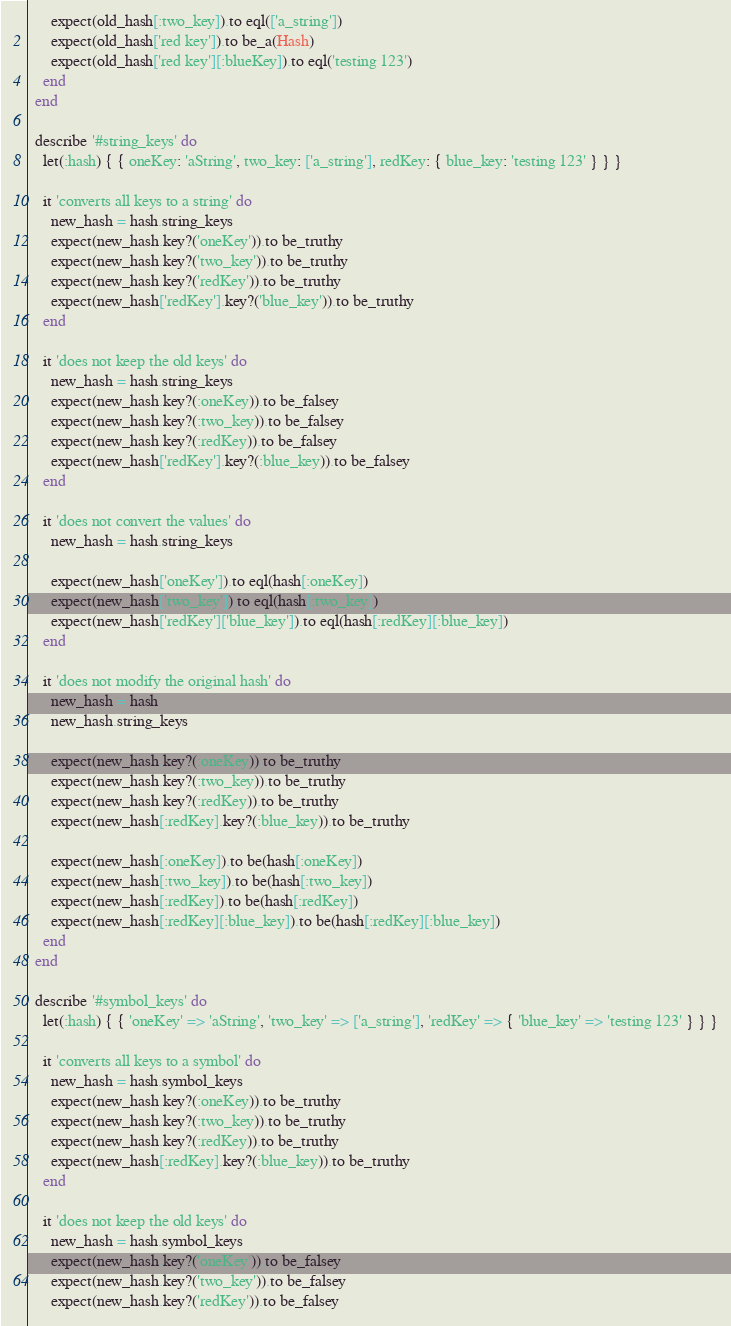<code> <loc_0><loc_0><loc_500><loc_500><_Ruby_>      expect(old_hash[:two_key]).to eql(['a_string'])
      expect(old_hash['red key']).to be_a(Hash)
      expect(old_hash['red key'][:blueKey]).to eql('testing 123')
    end
  end

  describe '#string_keys' do
    let(:hash) { { oneKey: 'aString', two_key: ['a_string'], redKey: { blue_key: 'testing 123' } } }

    it 'converts all keys to a string' do
      new_hash = hash.string_keys
      expect(new_hash.key?('oneKey')).to be_truthy
      expect(new_hash.key?('two_key')).to be_truthy
      expect(new_hash.key?('redKey')).to be_truthy
      expect(new_hash['redKey'].key?('blue_key')).to be_truthy
    end

    it 'does not keep the old keys' do
      new_hash = hash.string_keys
      expect(new_hash.key?(:oneKey)).to be_falsey
      expect(new_hash.key?(:two_key)).to be_falsey
      expect(new_hash.key?(:redKey)).to be_falsey
      expect(new_hash['redKey'].key?(:blue_key)).to be_falsey
    end

    it 'does not convert the values' do
      new_hash = hash.string_keys

      expect(new_hash['oneKey']).to eql(hash[:oneKey])
      expect(new_hash['two_key']).to eql(hash[:two_key])
      expect(new_hash['redKey']['blue_key']).to eql(hash[:redKey][:blue_key])
    end

    it 'does not modify the original hash' do
      new_hash = hash
      new_hash.string_keys

      expect(new_hash.key?(:oneKey)).to be_truthy
      expect(new_hash.key?(:two_key)).to be_truthy
      expect(new_hash.key?(:redKey)).to be_truthy
      expect(new_hash[:redKey].key?(:blue_key)).to be_truthy

      expect(new_hash[:oneKey]).to be(hash[:oneKey])
      expect(new_hash[:two_key]).to be(hash[:two_key])
      expect(new_hash[:redKey]).to be(hash[:redKey])
      expect(new_hash[:redKey][:blue_key]).to be(hash[:redKey][:blue_key])
    end
  end

  describe '#symbol_keys' do
    let(:hash) { { 'oneKey' => 'aString', 'two_key' => ['a_string'], 'redKey' => { 'blue_key' => 'testing 123' } } }

    it 'converts all keys to a symbol' do
      new_hash = hash.symbol_keys
      expect(new_hash.key?(:oneKey)).to be_truthy
      expect(new_hash.key?(:two_key)).to be_truthy
      expect(new_hash.key?(:redKey)).to be_truthy
      expect(new_hash[:redKey].key?(:blue_key)).to be_truthy
    end

    it 'does not keep the old keys' do
      new_hash = hash.symbol_keys
      expect(new_hash.key?('oneKey')).to be_falsey
      expect(new_hash.key?('two_key')).to be_falsey
      expect(new_hash.key?('redKey')).to be_falsey</code> 